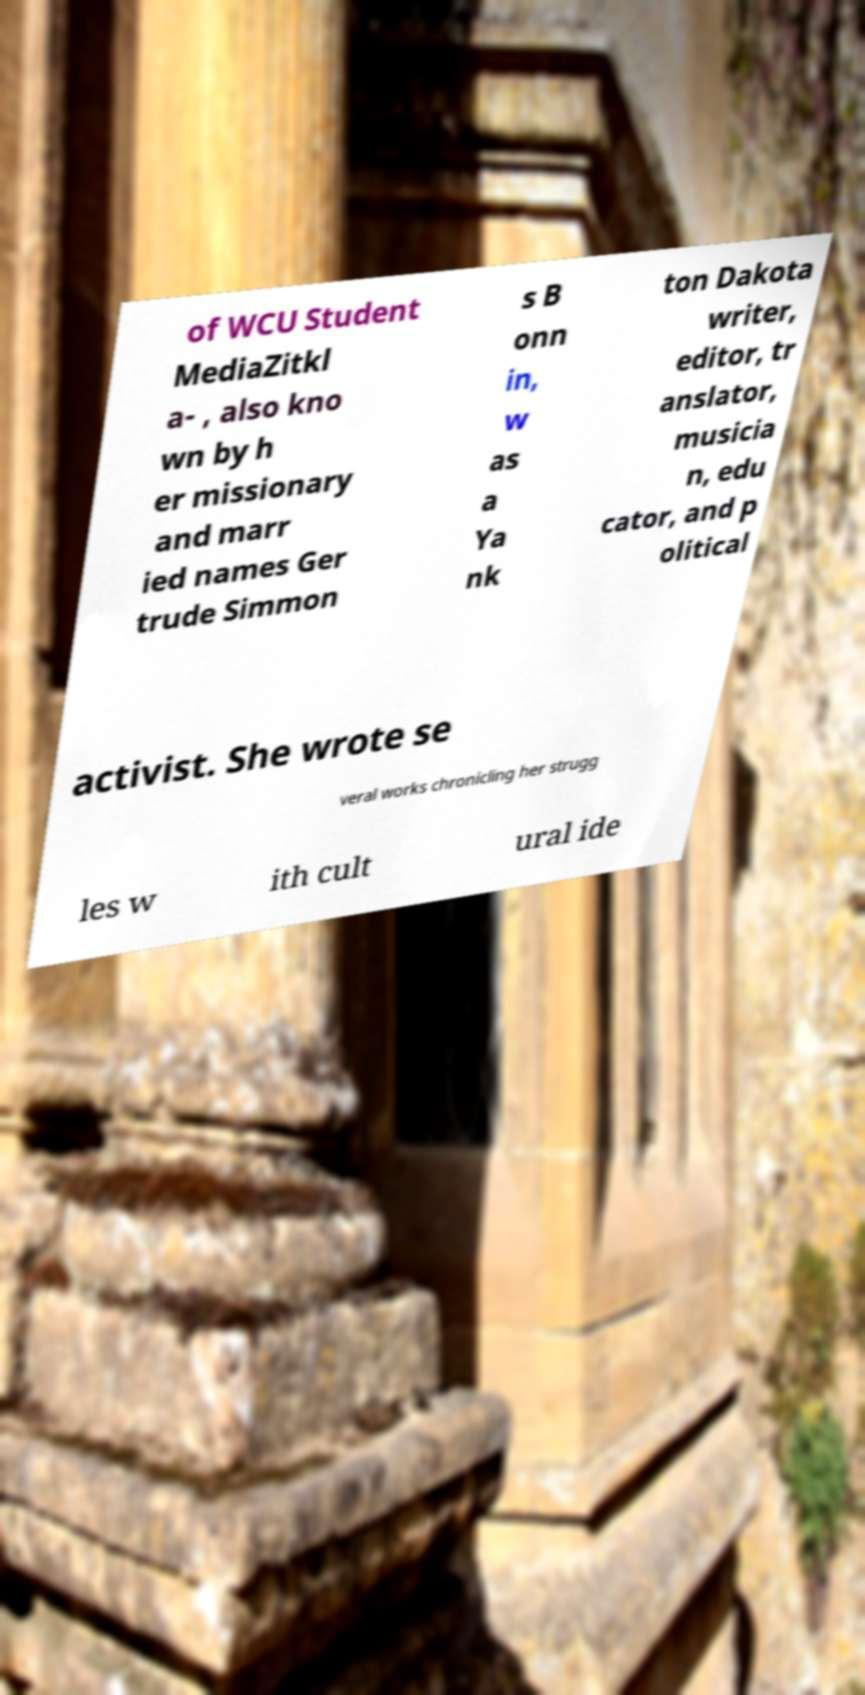Could you assist in decoding the text presented in this image and type it out clearly? of WCU Student MediaZitkl a- , also kno wn by h er missionary and marr ied names Ger trude Simmon s B onn in, w as a Ya nk ton Dakota writer, editor, tr anslator, musicia n, edu cator, and p olitical activist. She wrote se veral works chronicling her strugg les w ith cult ural ide 